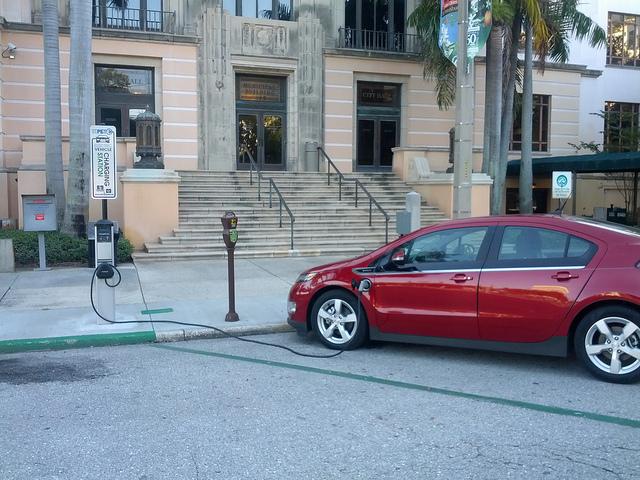Is this a new car?
Concise answer only. Yes. What color is this car?
Give a very brief answer. Red. What is stored in the building on the left?
Write a very short answer. Books. How many black cars?
Short answer required. 0. Is the red car a sports car?
Keep it brief. No. Is the dog on the backseat of the car?
Concise answer only. No. IS there a blue car in the picture?
Be succinct. No. How many tires are visible here?
Short answer required. 2. Is the car parked on a hill?
Keep it brief. No. Is this a farm scene?
Write a very short answer. No. What is the car connected too?
Be succinct. Hose. What color is the car?
Give a very brief answer. Red. What is in front of the car?
Give a very brief answer. Parking meter. 